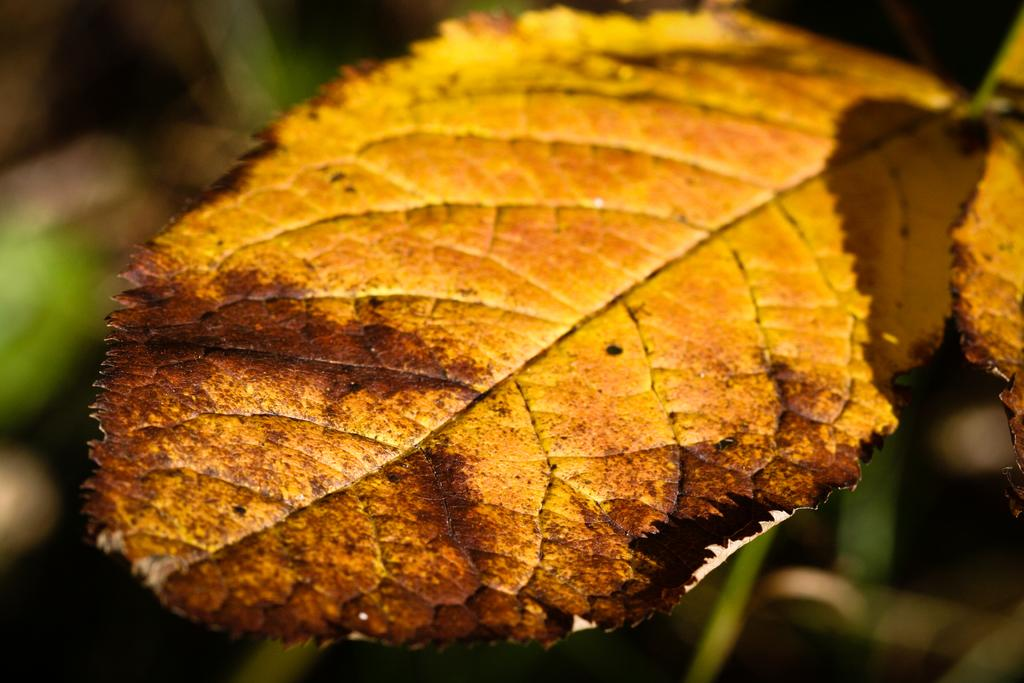What type of natural elements can be seen in the image? There are leaves in the image. Can you describe the background of the image? The background of the image is blurry. What type of shoes can be seen in the image? There are no shoes present in the image. What industry is depicted in the image? There is no industry depicted in the image; it features leaves and a blurry background. 